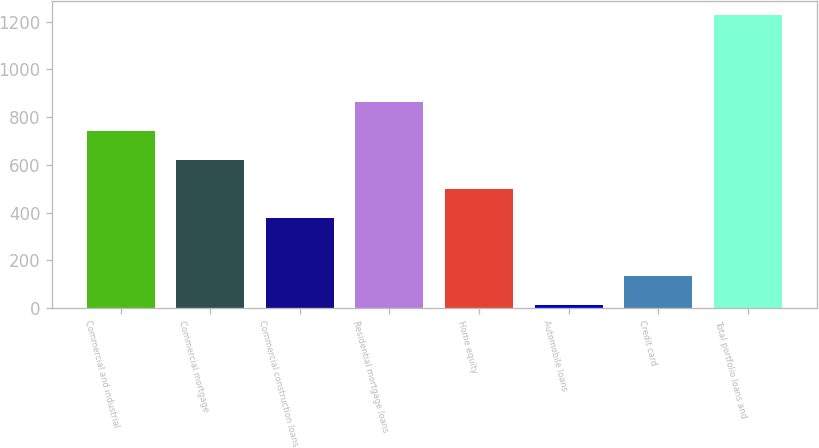<chart> <loc_0><loc_0><loc_500><loc_500><bar_chart><fcel>Commercial and industrial<fcel>Commercial mortgage<fcel>Commercial construction loans<fcel>Residential mortgage loans<fcel>Home equity<fcel>Automobile loans<fcel>Credit card<fcel>Total portfolio loans and<nl><fcel>741<fcel>619.5<fcel>376.5<fcel>862.5<fcel>498<fcel>12<fcel>133.5<fcel>1227<nl></chart> 